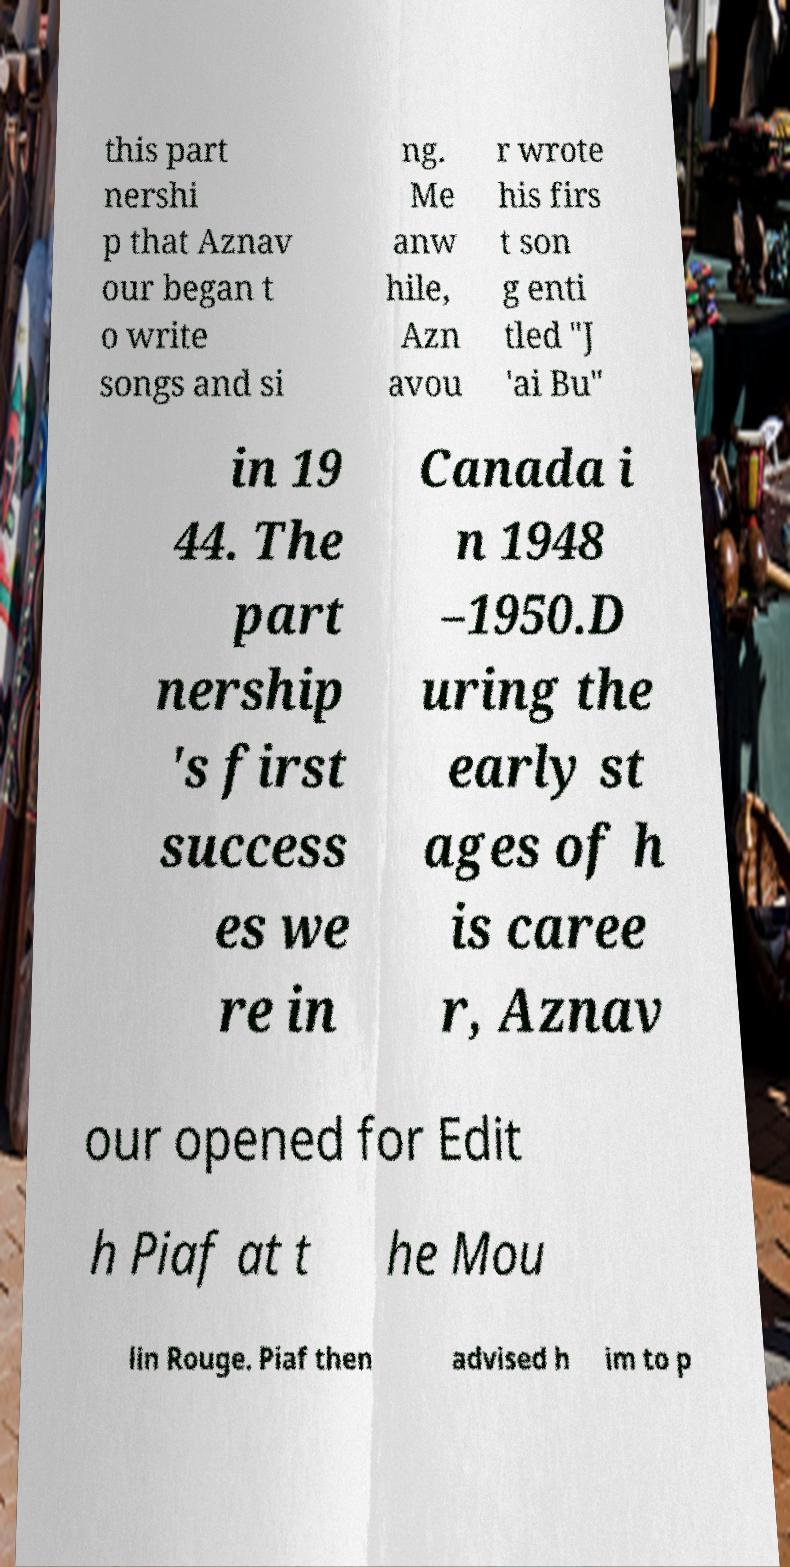For documentation purposes, I need the text within this image transcribed. Could you provide that? this part nershi p that Aznav our began t o write songs and si ng. Me anw hile, Azn avou r wrote his firs t son g enti tled "J 'ai Bu" in 19 44. The part nership 's first success es we re in Canada i n 1948 –1950.D uring the early st ages of h is caree r, Aznav our opened for Edit h Piaf at t he Mou lin Rouge. Piaf then advised h im to p 